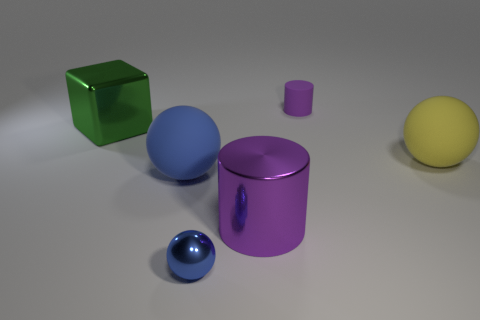Subtract all large blue spheres. How many spheres are left? 2 Subtract all blue spheres. How many spheres are left? 1 Add 1 large spheres. How many objects exist? 7 Subtract all cylinders. How many objects are left? 4 Subtract all gray cylinders. Subtract all purple spheres. How many cylinders are left? 2 Subtract all yellow cylinders. How many cyan balls are left? 0 Subtract all yellow balls. Subtract all small purple rubber objects. How many objects are left? 4 Add 6 blue rubber objects. How many blue rubber objects are left? 7 Add 2 purple cylinders. How many purple cylinders exist? 4 Subtract 0 brown cubes. How many objects are left? 6 